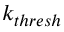Convert formula to latex. <formula><loc_0><loc_0><loc_500><loc_500>k _ { t h r e s h }</formula> 